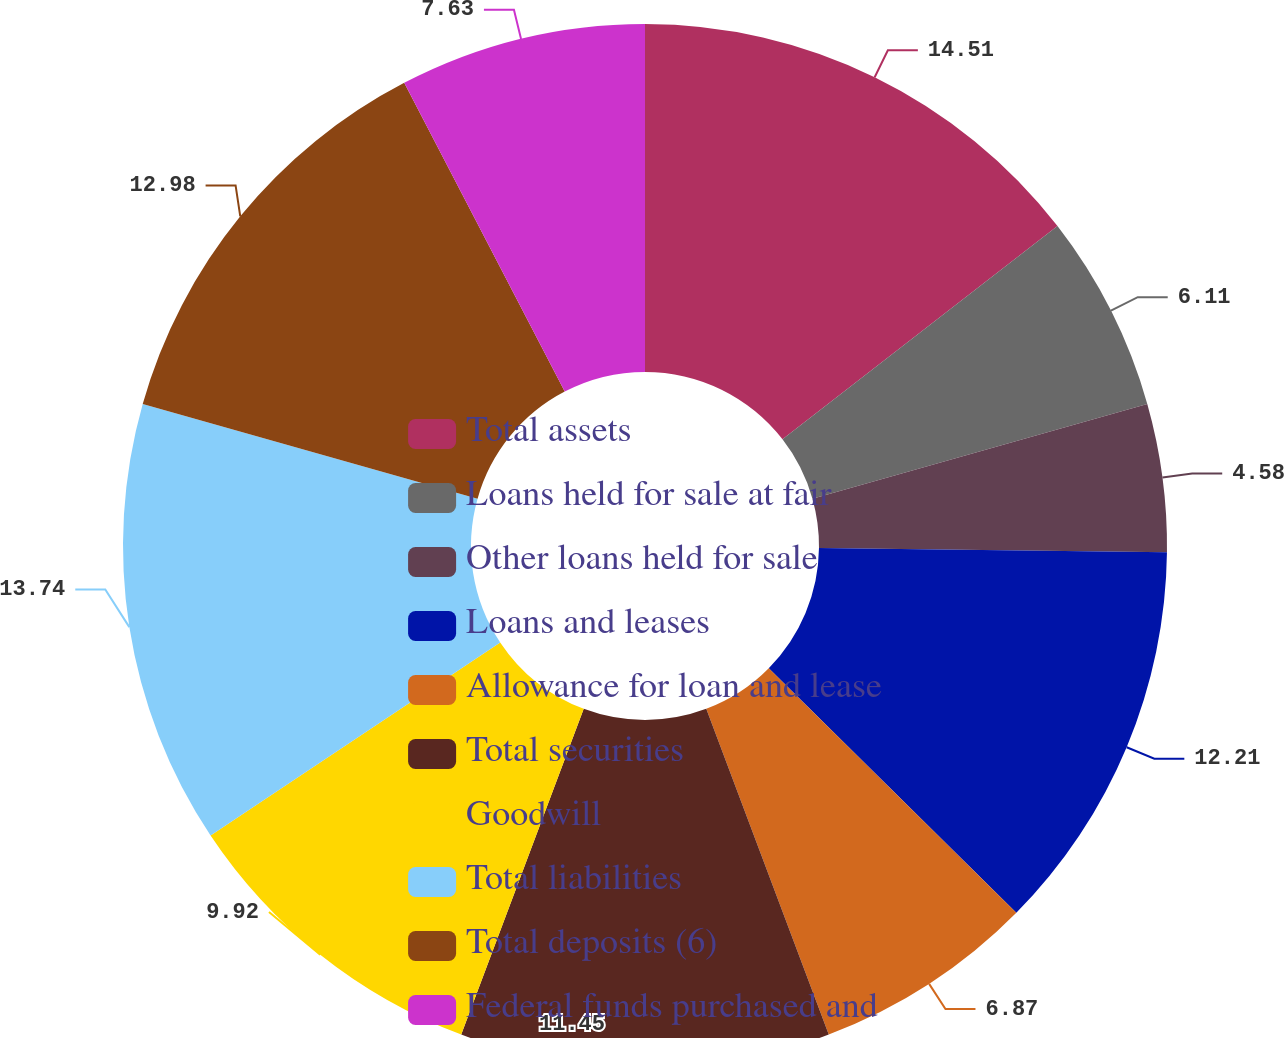Convert chart. <chart><loc_0><loc_0><loc_500><loc_500><pie_chart><fcel>Total assets<fcel>Loans held for sale at fair<fcel>Other loans held for sale<fcel>Loans and leases<fcel>Allowance for loan and lease<fcel>Total securities<fcel>Goodwill<fcel>Total liabilities<fcel>Total deposits (6)<fcel>Federal funds purchased and<nl><fcel>14.5%<fcel>6.11%<fcel>4.58%<fcel>12.21%<fcel>6.87%<fcel>11.45%<fcel>9.92%<fcel>13.74%<fcel>12.98%<fcel>7.63%<nl></chart> 